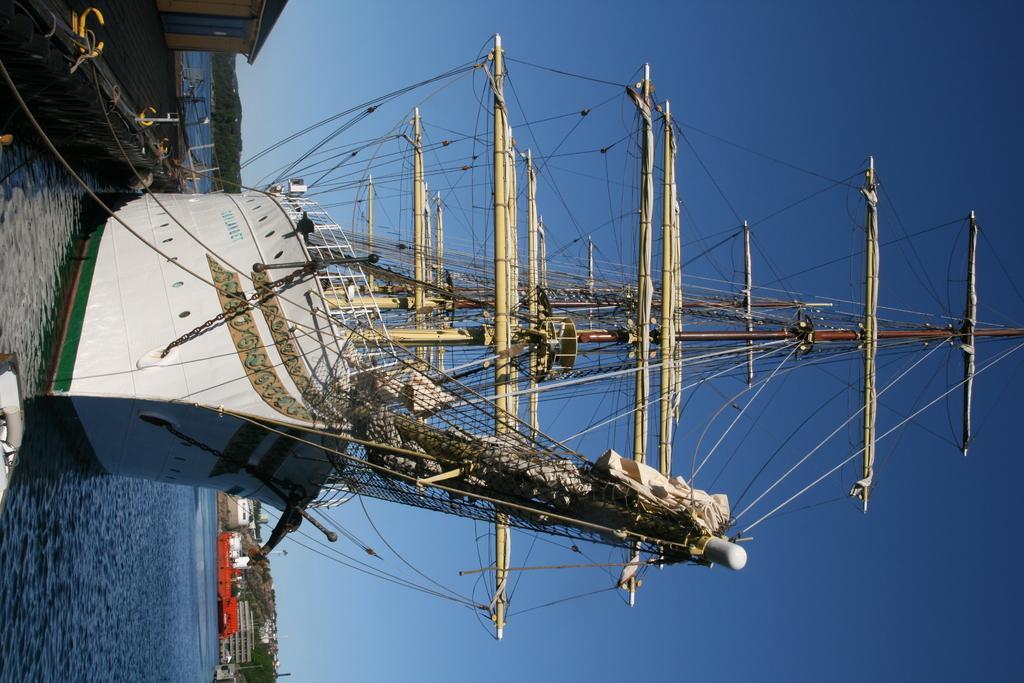Could you give a brief overview of what you see in this image? In this picture, we can see a ship, with some objects, like poles, n, wires, and we can see water, floor, house, mountains, buildings, and the sky. 